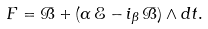<formula> <loc_0><loc_0><loc_500><loc_500>F = \mathcal { B } + ( \alpha \, \mathcal { E } - i _ { \beta } \, \mathcal { B } ) \wedge d t .</formula> 